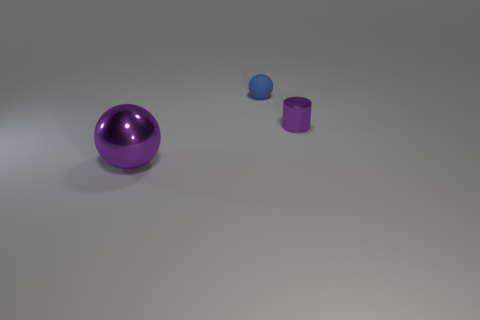Does the tiny cylinder have the same color as the large shiny thing?
Your answer should be compact. Yes. Are there any other things that are the same material as the tiny blue sphere?
Ensure brevity in your answer.  No. There is a small metallic thing that is the same color as the big metallic thing; what shape is it?
Your answer should be very brief. Cylinder. What material is the purple thing on the right side of the shiny thing that is to the left of the purple metallic object behind the purple metal ball made of?
Ensure brevity in your answer.  Metal. The cylinder that is the same material as the large purple sphere is what size?
Offer a terse response. Small. Is there a ball that has the same color as the tiny metallic thing?
Keep it short and to the point. Yes. There is a purple metal cylinder; does it have the same size as the ball that is behind the cylinder?
Give a very brief answer. Yes. How many matte objects are on the left side of the metal thing that is left of the ball behind the cylinder?
Offer a very short reply. 0. There is another metal thing that is the same color as the big metallic object; what size is it?
Make the answer very short. Small. There is a blue ball; are there any purple metal objects in front of it?
Your answer should be very brief. Yes. 